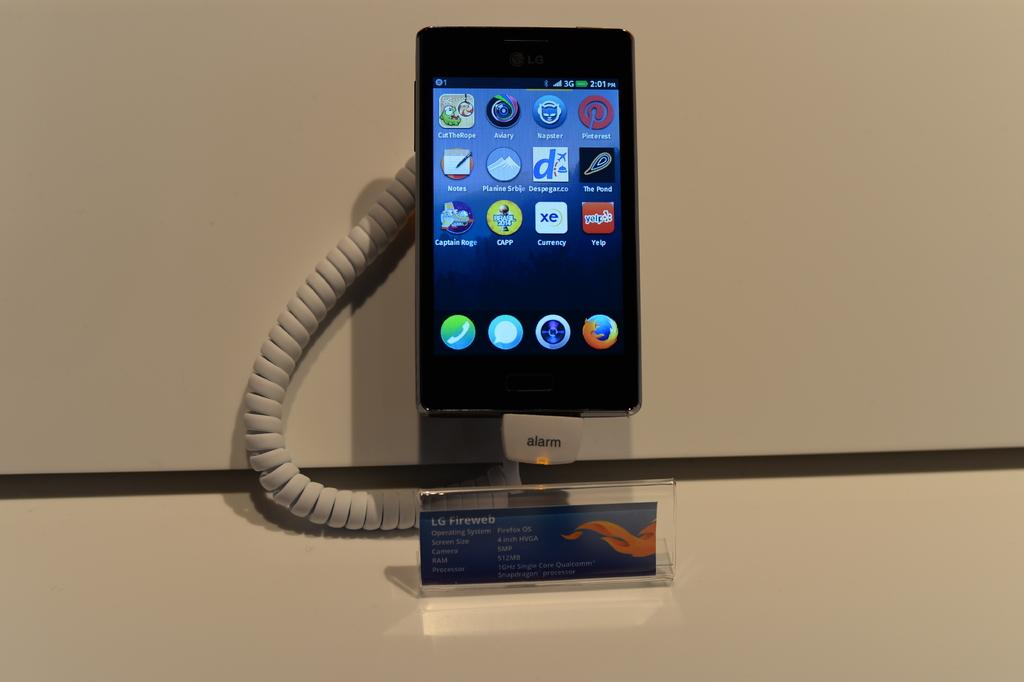<image>
Describe the image concisely. An LG Fireweb smartphone with Firefox OS operating system 